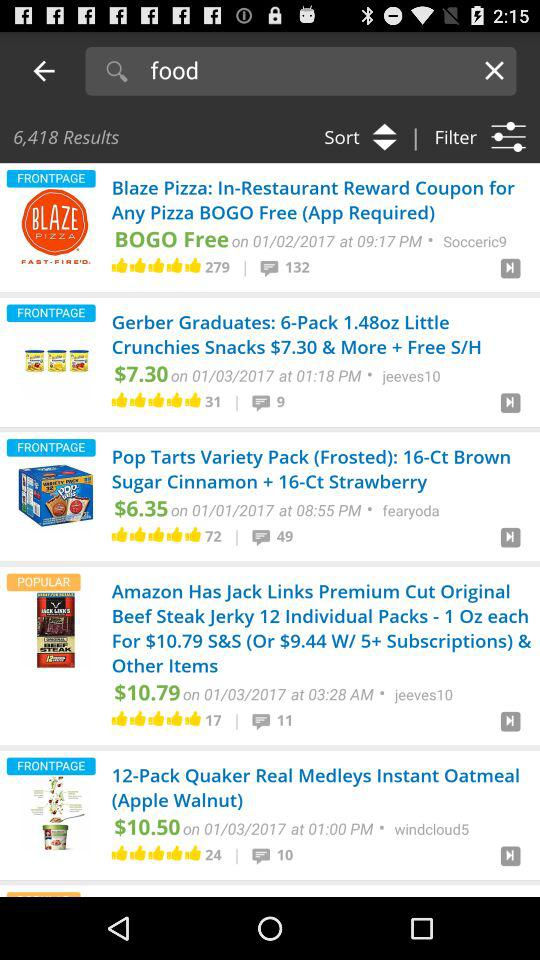How many results are shown? There are 6,418 results shown. 